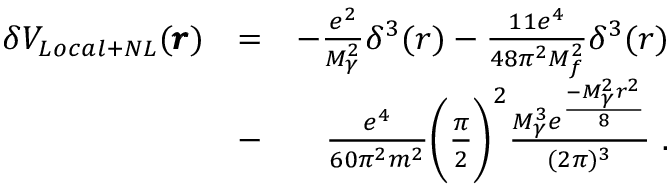<formula> <loc_0><loc_0><loc_500><loc_500>\begin{array} { r l r } { \delta V _ { L o c a l + N L } ( \pm b { r } ) } & { = } & { - \frac { e ^ { 2 } } { M _ { \gamma } ^ { 2 } } \delta ^ { 3 } ( r ) - \frac { 1 1 e ^ { 4 } } { 4 8 \pi ^ { 2 } M _ { f } ^ { 2 } } \delta ^ { 3 } ( r ) } \\ & { - } & { \frac { e ^ { 4 } } { 6 0 \pi ^ { 2 } m ^ { 2 } } \left ( \frac { \pi } { 2 } \right ) ^ { 2 } \frac { M _ { \gamma } ^ { 3 } e ^ { \frac { - M _ { \gamma } ^ { 2 } r ^ { 2 } } { 8 } } } { ( 2 \pi ) ^ { 3 } } \ . } \end{array}</formula> 